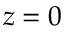<formula> <loc_0><loc_0><loc_500><loc_500>z = 0</formula> 